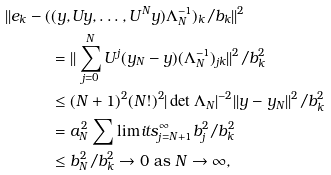Convert formula to latex. <formula><loc_0><loc_0><loc_500><loc_500>| | e _ { k } - ( & ( y , U y , \dots , U ^ { N } y ) \Lambda _ { N } ^ { - 1 } ) _ { k } / b _ { k } | | ^ { 2 } \\ & = | | \sum _ { j = 0 } ^ { N } U ^ { j } ( y _ { N } - y ) ( \Lambda _ { N } ^ { - 1 } ) _ { j k } | | ^ { 2 } / b _ { k } ^ { 2 } \\ & \leq ( N + 1 ) ^ { 2 } ( N ! ) ^ { 2 } | \det \Lambda _ { N } | ^ { - 2 } | | y - y _ { N } | | ^ { 2 } / b _ { k } ^ { 2 } \\ & = a _ { N } ^ { 2 } \sum \lim i t s _ { j = N + 1 } ^ { \infty } b _ { j } ^ { 2 } / b _ { k } ^ { 2 } \\ & \leq b _ { N } ^ { 2 } / b _ { k } ^ { 2 } \to 0 \text { as } N \to \infty ,</formula> 